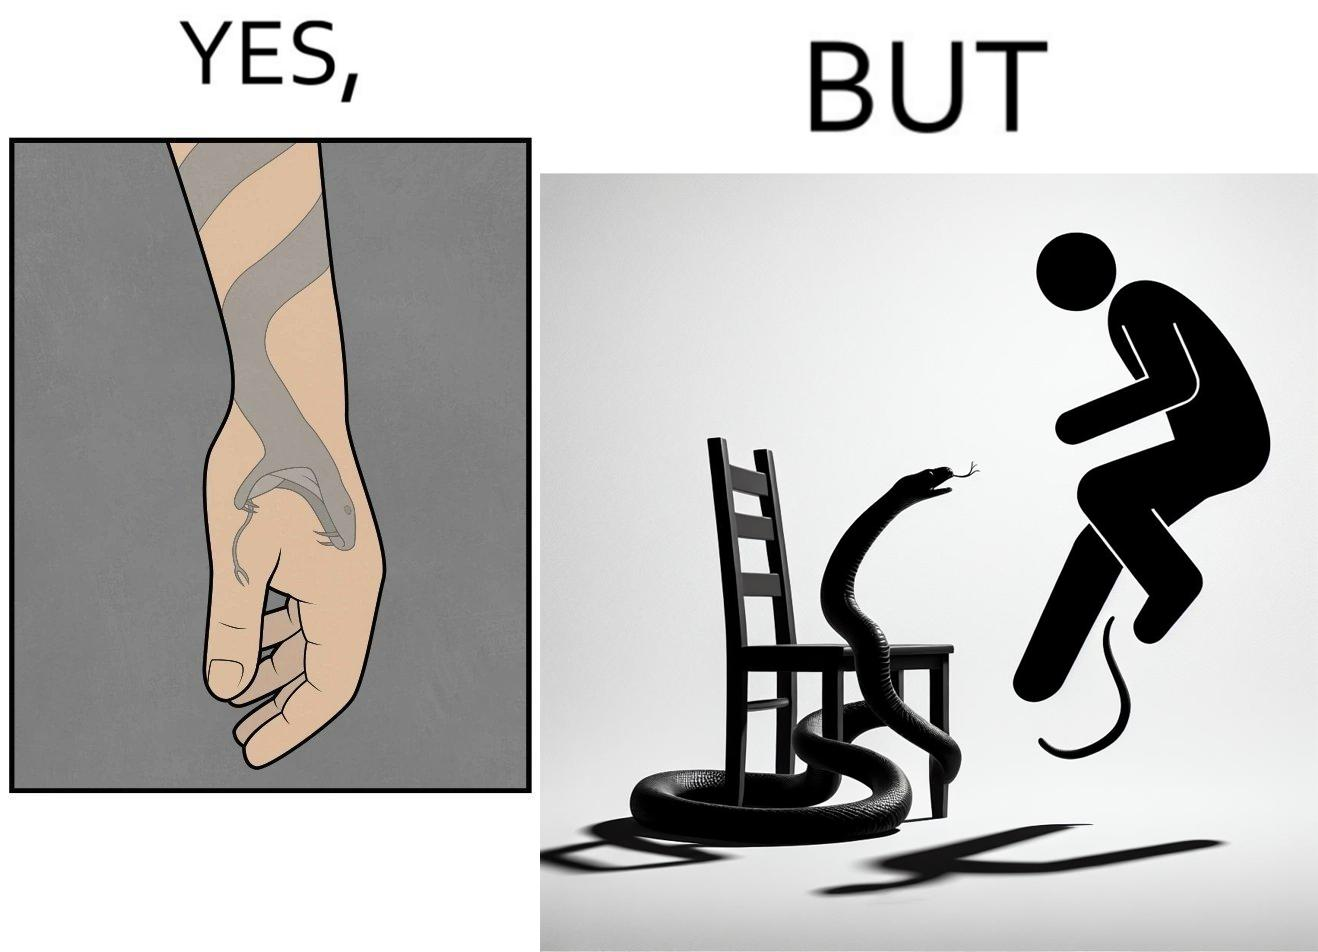Would you classify this image as satirical? Yes, this image is satirical. 